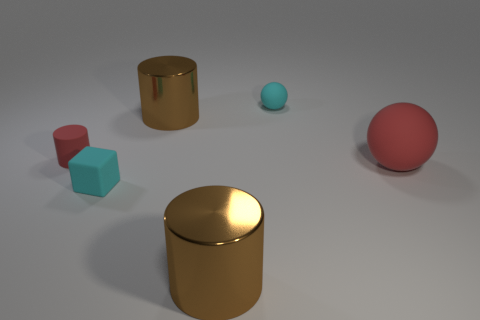Are there any red cylinders in front of the cyan matte block?
Provide a short and direct response. No. Is there a green cube made of the same material as the red cylinder?
Give a very brief answer. No. There is a matte object that is the same color as the tiny rubber cylinder; what size is it?
Ensure brevity in your answer.  Large. How many balls are either matte things or big red matte objects?
Your answer should be very brief. 2. Is the number of big metallic things that are in front of the big sphere greater than the number of small matte cylinders that are in front of the small red rubber object?
Provide a short and direct response. Yes. What number of rubber objects are the same color as the small matte cube?
Your answer should be compact. 1. The cube that is the same material as the big red ball is what size?
Make the answer very short. Small. How many objects are either brown cylinders behind the cyan block or red cylinders?
Your answer should be very brief. 2. Do the big cylinder that is behind the small block and the small rubber ball have the same color?
Offer a terse response. No. What size is the other rubber thing that is the same shape as the large red thing?
Give a very brief answer. Small. 